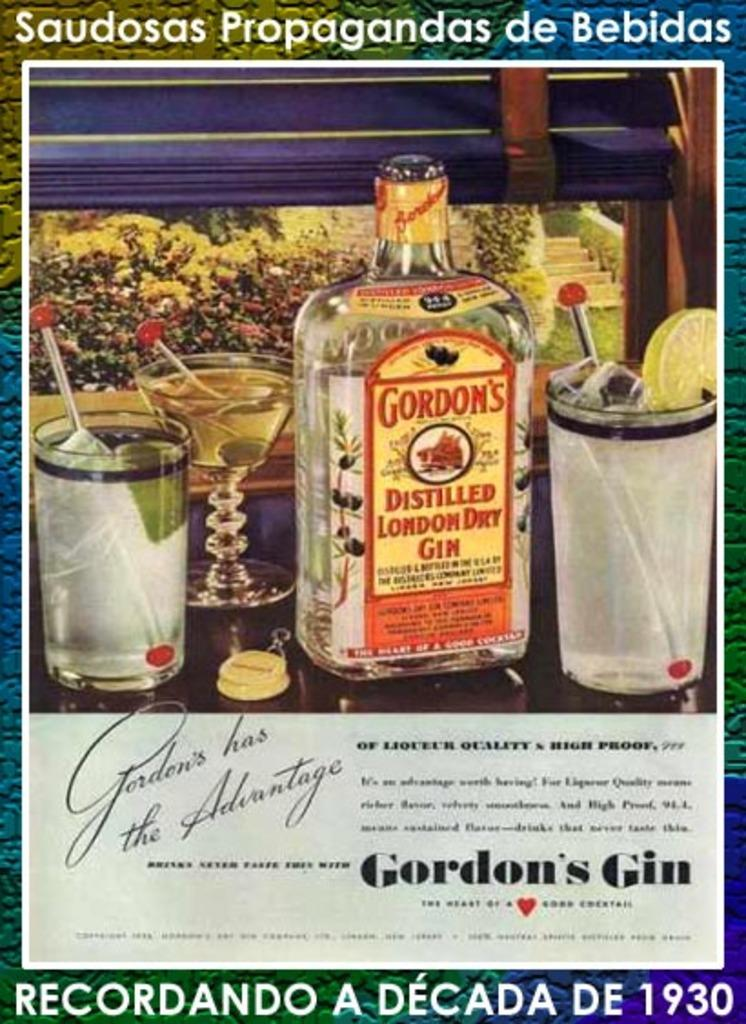<image>
Offer a succinct explanation of the picture presented. A poster shows a bottle of Gordon's Distilled London Dry Gin with some glasses of mixed drinks. 